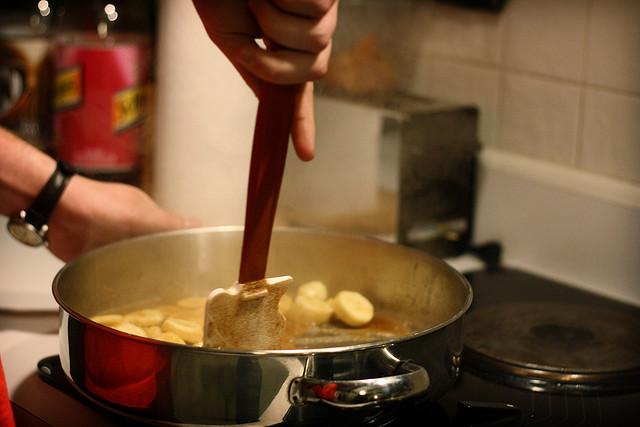What is this person doing?
Give a very brief answer. Cooking. Are those slices of banana in the pan?
Quick response, please. Yes. What ingredients are used to make the caramel sauce in the pan?
Quick response, please. Bananas. 